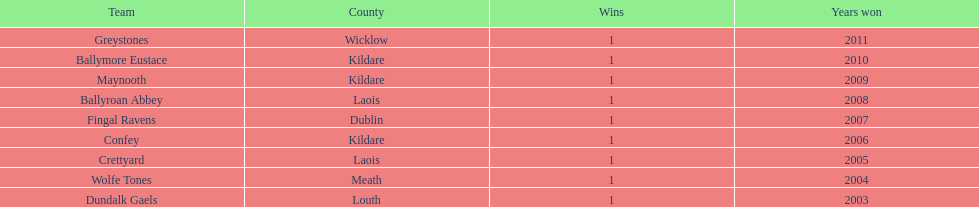How many wins did confey have? 1. 